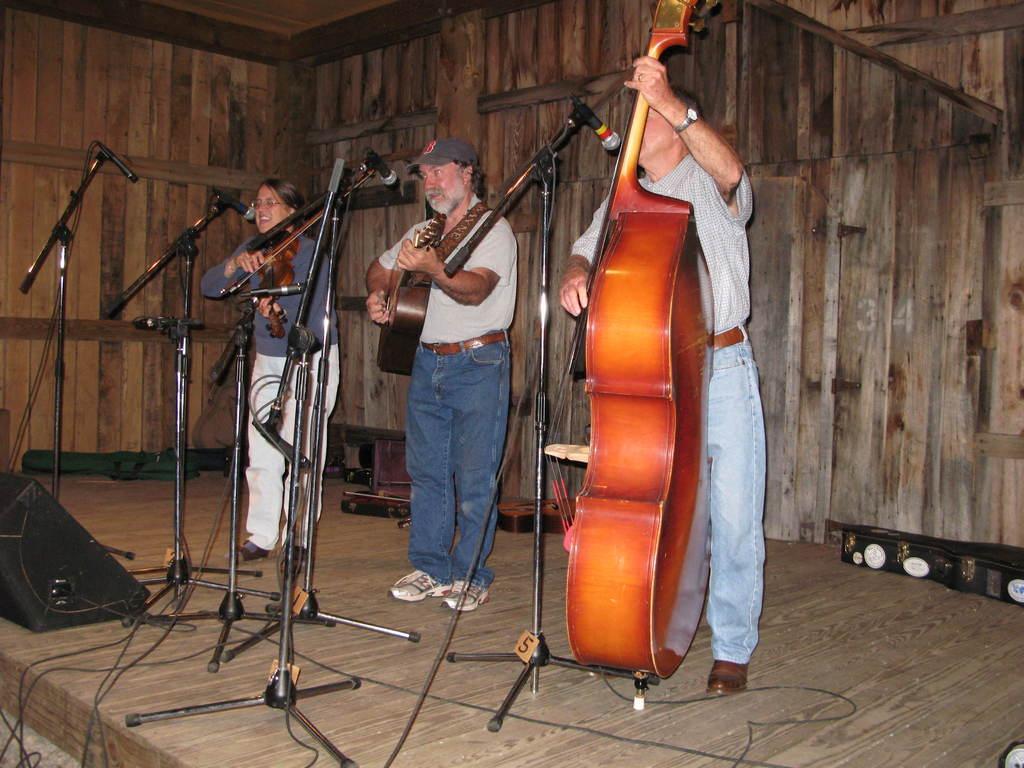In one or two sentences, can you explain what this image depicts? In this image there are three person who playing a different size of guitar. This person is playing a big red guitar. There are five mics in-front of them. On the background there is a wooden wall. On the left side there is a black speaker and on the right there is a box. 